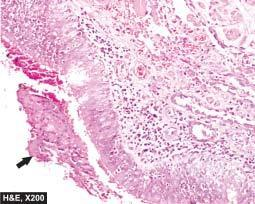s viral dna sloughed off at places with exudate of muco-pus in the lumen?
Answer the question using a single word or phrase. No 